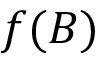<formula> <loc_0><loc_0><loc_500><loc_500>f ( B )</formula> 